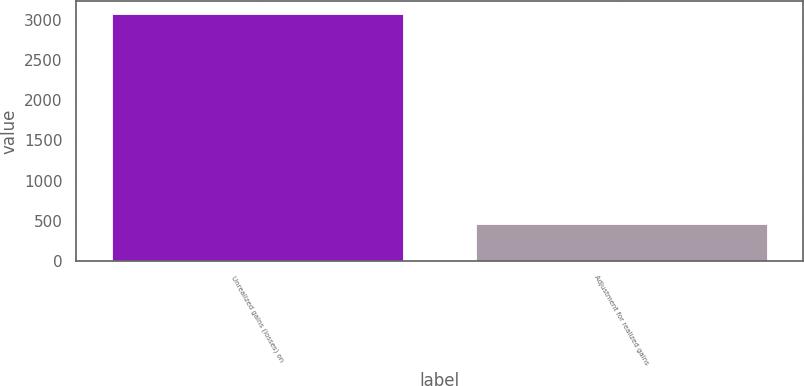<chart> <loc_0><loc_0><loc_500><loc_500><bar_chart><fcel>Unrealized gains (losses) on<fcel>Adjustment for realized gains<nl><fcel>3073.9<fcel>456.4<nl></chart> 